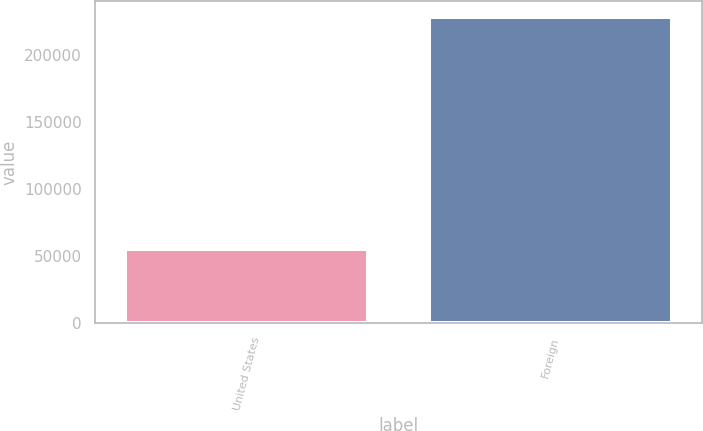Convert chart. <chart><loc_0><loc_0><loc_500><loc_500><bar_chart><fcel>United States<fcel>Foreign<nl><fcel>55279<fcel>228623<nl></chart> 